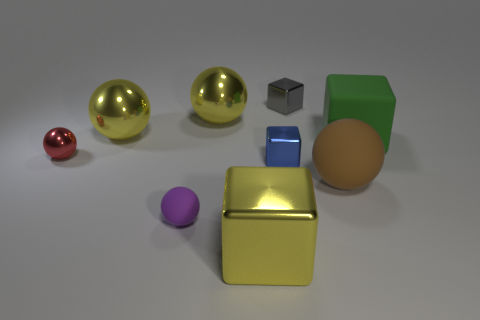Is the color of the big metal cube the same as the big shiny object that is left of the tiny purple matte thing?
Your answer should be compact. Yes. How big is the matte sphere that is in front of the large ball that is right of the tiny object behind the red shiny thing?
Your response must be concise. Small. There is a gray thing that is the same size as the red metal sphere; what is its material?
Make the answer very short. Metal. Is there a yellow block that has the same size as the red object?
Your response must be concise. No. There is a block behind the matte cube; is its size the same as the yellow cube?
Provide a succinct answer. No. The small thing that is behind the tiny purple object and left of the blue object has what shape?
Provide a short and direct response. Sphere. Is the number of big cubes that are behind the small purple ball greater than the number of big cyan rubber cylinders?
Provide a short and direct response. Yes. There is a brown sphere that is the same material as the purple thing; what is its size?
Your response must be concise. Large. How many balls have the same color as the big shiny cube?
Make the answer very short. 2. There is a big metallic ball that is on the left side of the small purple matte thing; does it have the same color as the big metal block?
Offer a very short reply. Yes. 